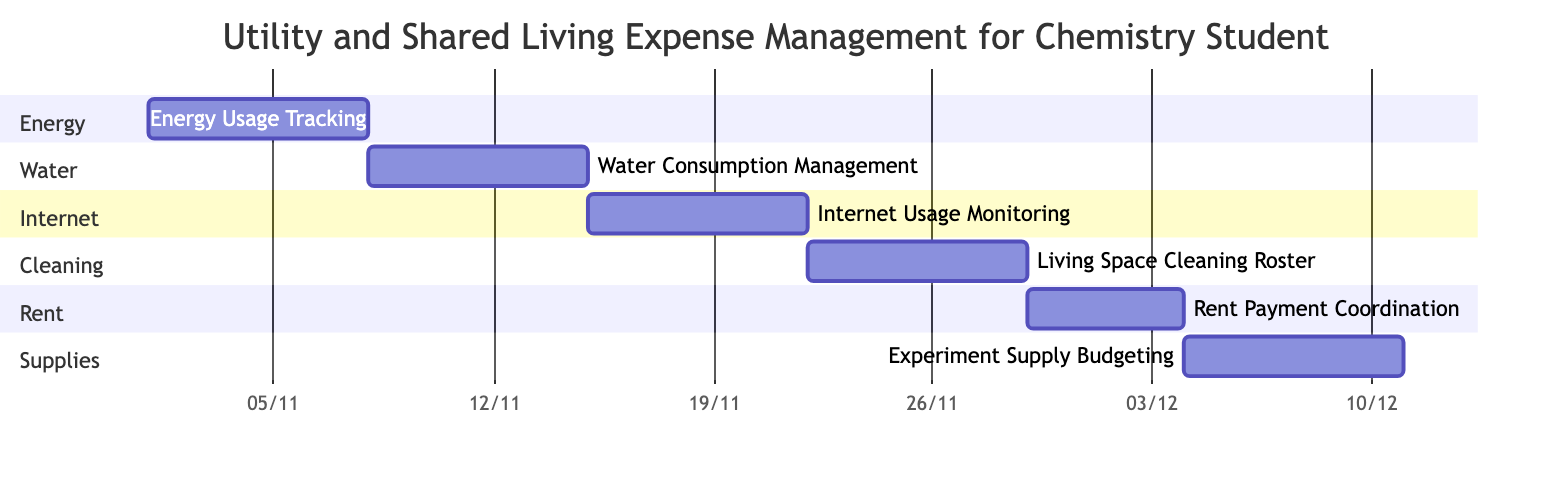What is the duration of the Energy Usage Tracking task? The Energy Usage Tracking task starts on November 1, 2023, and ends on November 7, 2023. Counting from the start date to the end date, including both days, gives a total of 7 days.
Answer: 7 days Which task follows Water Consumption Management? Water Consumption Management ends on November 14, 2023, and the next task, Internet Usage Monitoring, starts on November 15, 2023. Since the start of Internet Usage Monitoring is directly after the end of Water Consumption Management, it follows this task.
Answer: Internet Usage Monitoring How many total tasks are included in the Gantt chart? The diagram lists a total of 6 tasks under various categories such as Energy, Water, Internet, Cleaning, Rent, and Supplies. Counting all listed tasks results in six.
Answer: 6 What is the main focus of the Cleaning section? The Cleaning section contains one task, which is Living Space Cleaning Roster. This task is focused on scheduling cleaning for shared living spaces, including lab areas, kitchen, and bathroom.
Answer: Living Space Cleaning Roster How do the tasks related to expenses and budgeting relate in time? Rent Payment Coordination runs from November 29, 2023, to December 3, 2023, while Experiment Supply Budgeting starts on December 4, 2023. Thus, Rent Payment Coordination concludes the week before Experiment Supply Budgeting begins, showing that planning for rent is completed prior to budgeting for supplies.
Answer: Sequentially related What is the purpose of the Internet Usage Monitoring task? The Internet Usage Monitoring task focuses on tracking internet data usage for various activities, including research, online classes, and leisure. This is essential for managing shared living expenses.
Answer: Track internet data usage How many days are allocated for Rent Payment Coordination? The Rent Payment Coordination task starts on November 29, 2023, and ends on December 3, 2023. Counting these days gives a total of 5 days designated for this task.
Answer: 5 days 